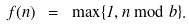<formula> <loc_0><loc_0><loc_500><loc_500>f ( n ) \ = \ \max \{ 1 , n \bmod b \} .</formula> 